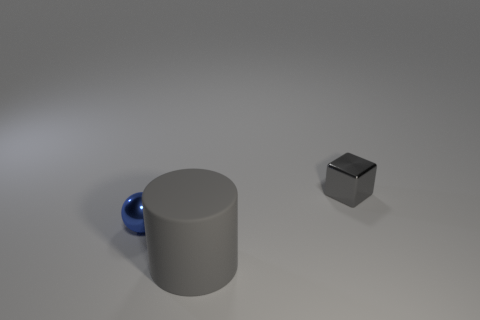Is the number of tiny blue objects behind the tiny gray shiny object the same as the number of tiny blue matte balls?
Your answer should be very brief. Yes. Are the small thing that is behind the tiny blue object and the big gray cylinder made of the same material?
Provide a succinct answer. No. How many tiny things are yellow rubber things or gray metal objects?
Offer a very short reply. 1. The block has what size?
Your answer should be compact. Small. Do the blue metallic thing and the gray thing that is in front of the blue thing have the same size?
Keep it short and to the point. No. How many blue things are either big rubber things or tiny things?
Your response must be concise. 1. What number of red matte blocks are there?
Your answer should be compact. 0. How big is the thing on the left side of the cylinder?
Provide a short and direct response. Small. Does the blue ball have the same size as the gray shiny object?
Your answer should be very brief. Yes. What number of things are either large gray metal cylinders or things to the left of the gray shiny block?
Provide a short and direct response. 2. 